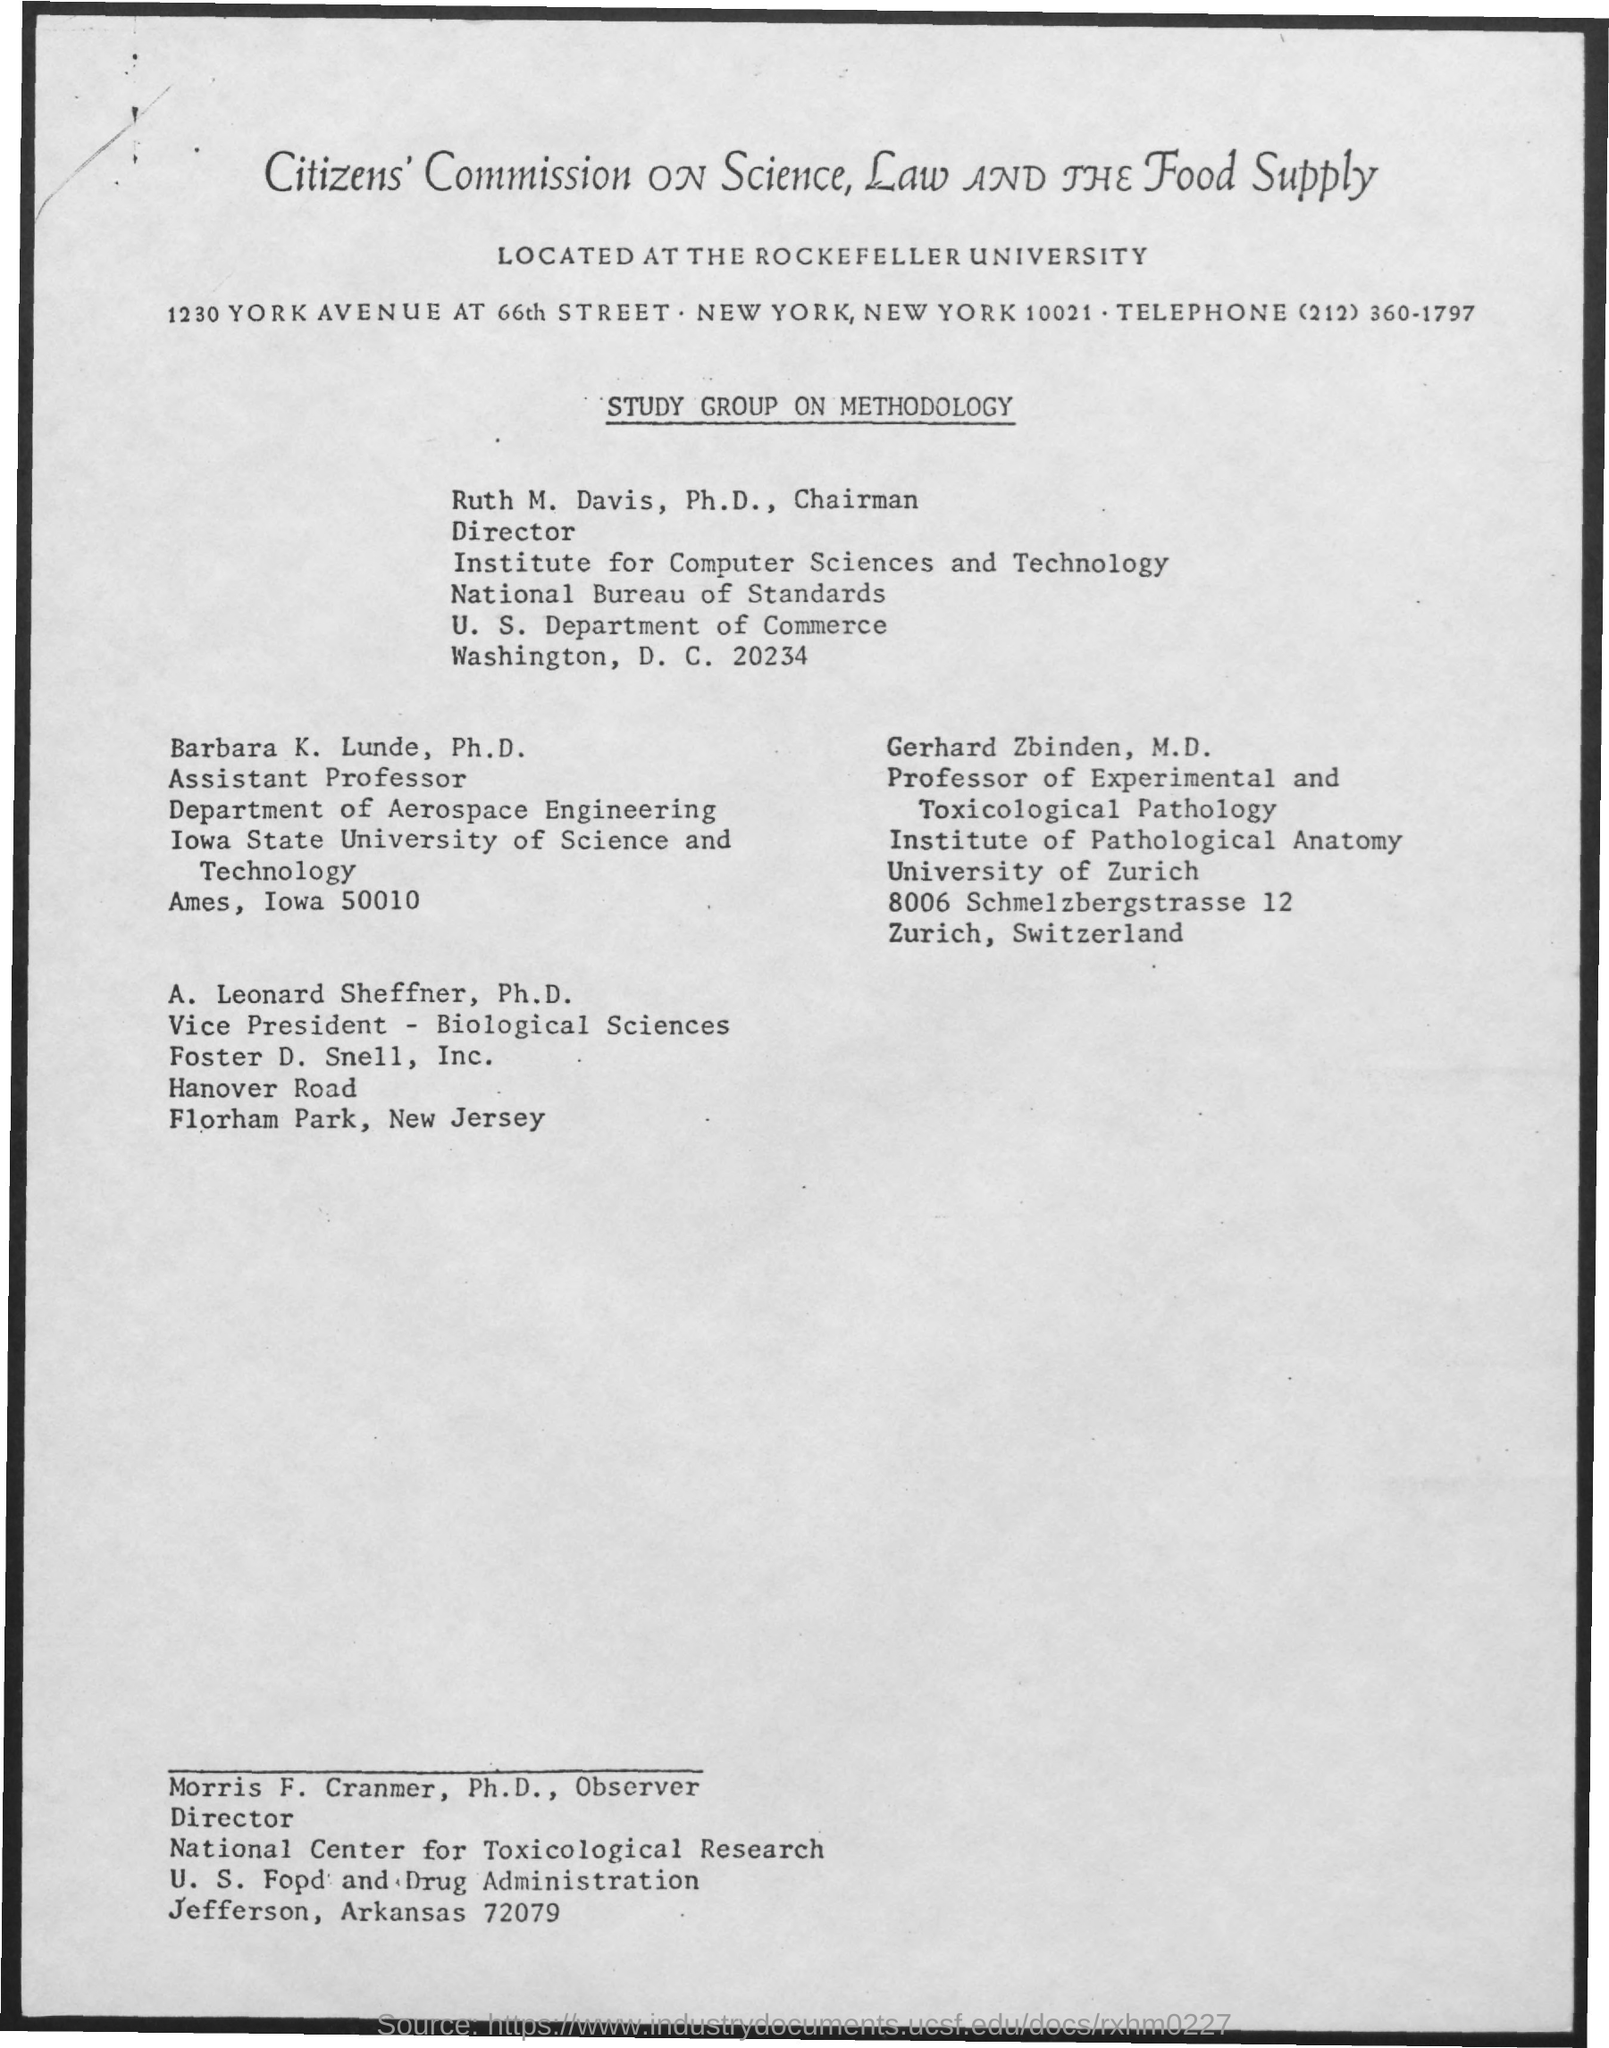Who is the chairman of Study group on methodology?
Your answer should be very brief. Ruth M. Davis, Ph.D. What is the designation of Gerhard Zbinden, M.D.?
Give a very brief answer. Professor of Experimental and Toxicological Pathology. 